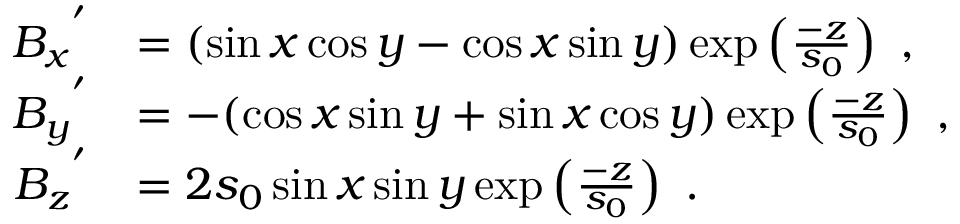Convert formula to latex. <formula><loc_0><loc_0><loc_500><loc_500>\begin{array} { r l } { { B _ { x } } ^ { ^ { \prime } } } & { = ( \sin x \cos y - \cos x \sin y ) \exp \left ( \frac { - z } { s _ { 0 } } \right ) , } \\ { { B _ { y } } ^ { ^ { \prime } } } & { = - ( \cos x \sin y + \sin x \cos y ) \exp \left ( \frac { - z } { s _ { 0 } } \right ) , } \\ { { B _ { z } } ^ { ^ { \prime } } } & { = 2 s _ { 0 } \sin x \sin y \exp \left ( \frac { - z } { s _ { 0 } } \right ) . } \end{array}</formula> 